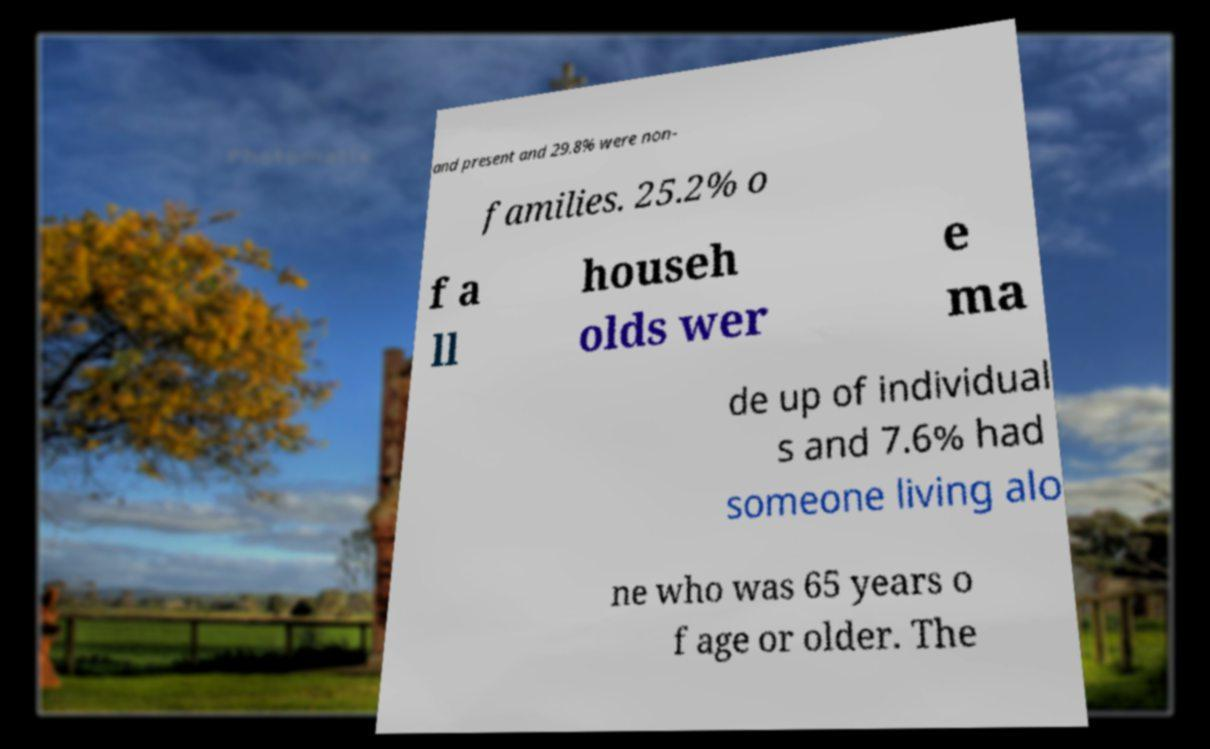Could you extract and type out the text from this image? and present and 29.8% were non- families. 25.2% o f a ll househ olds wer e ma de up of individual s and 7.6% had someone living alo ne who was 65 years o f age or older. The 